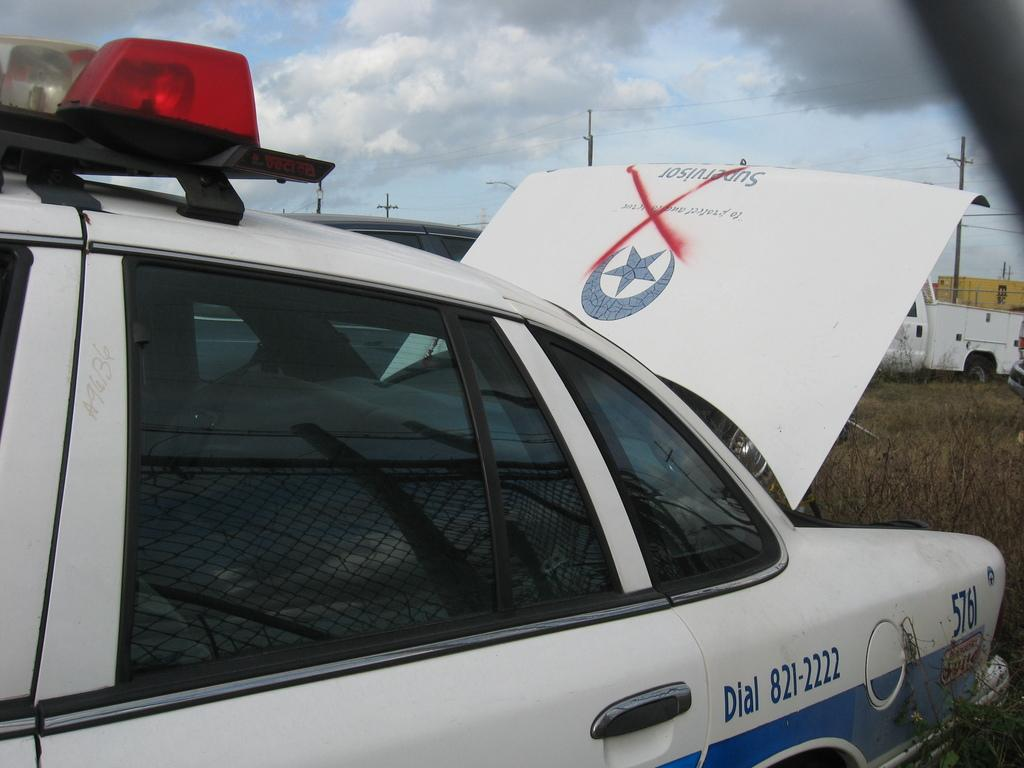<image>
Render a clear and concise summary of the photo. Police car 576 sits with the trunk open and a red x painted on it. 